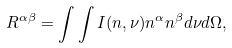Convert formula to latex. <formula><loc_0><loc_0><loc_500><loc_500>R ^ { \alpha \beta } = \int \int I ( { n } , \nu ) n ^ { \alpha } n ^ { \beta } d \nu d \Omega ,</formula> 